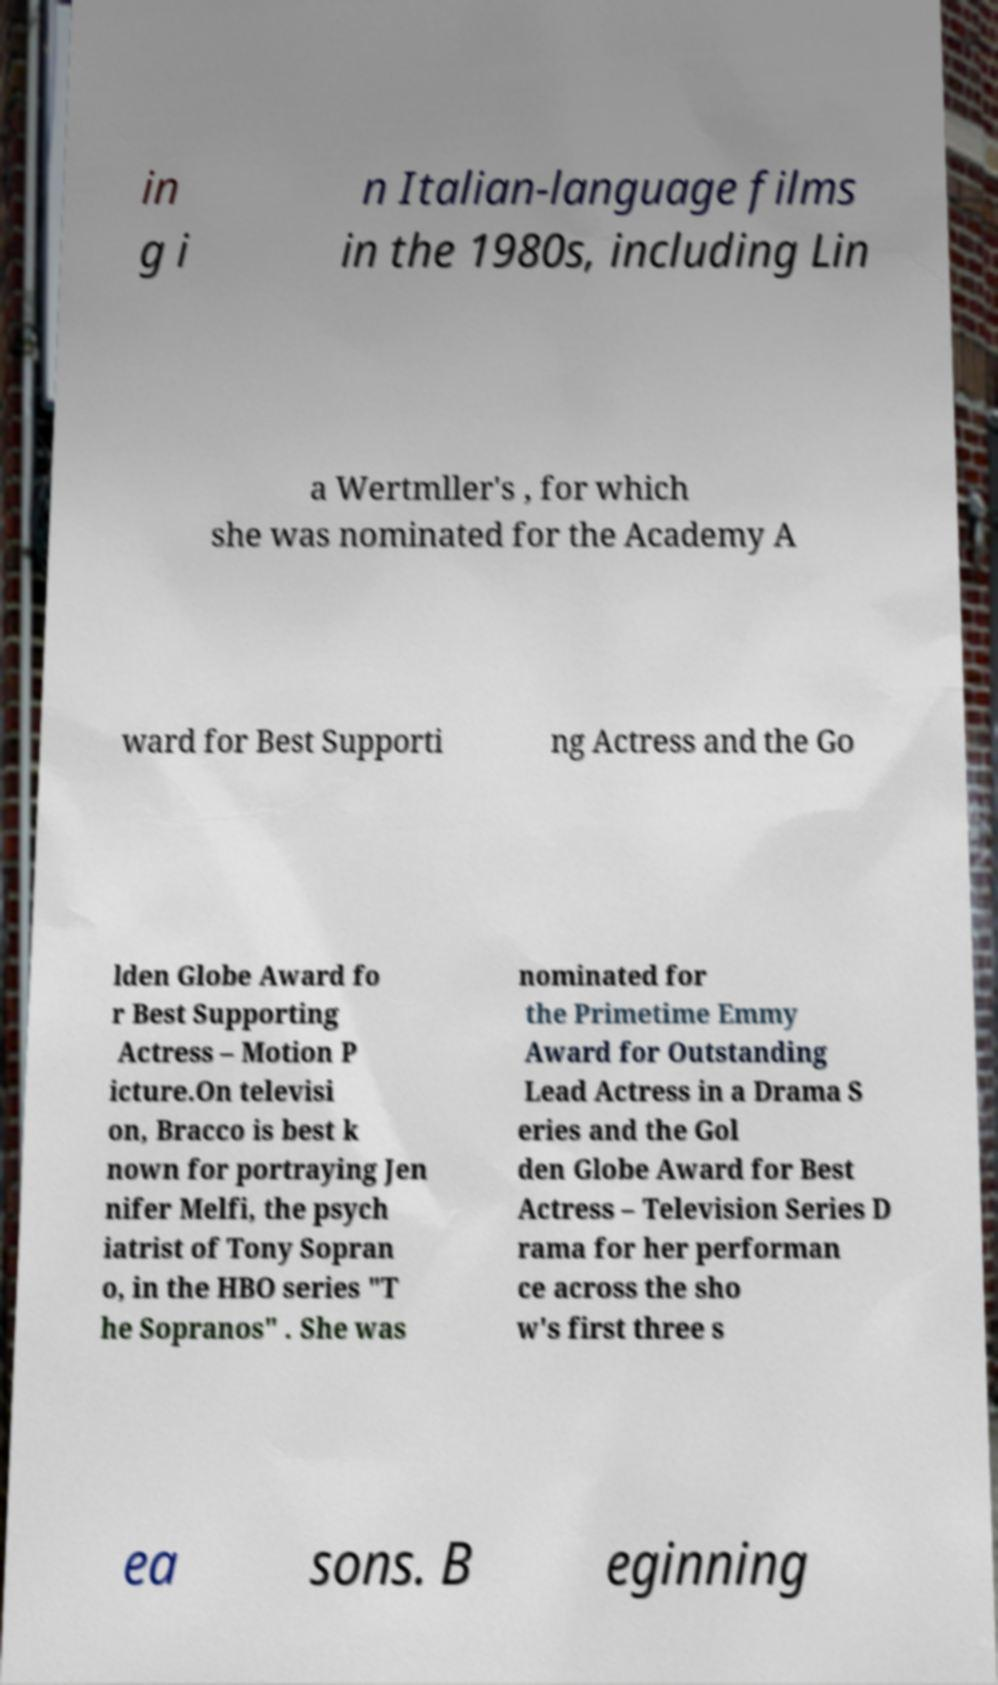Can you read and provide the text displayed in the image?This photo seems to have some interesting text. Can you extract and type it out for me? in g i n Italian-language films in the 1980s, including Lin a Wertmller's , for which she was nominated for the Academy A ward for Best Supporti ng Actress and the Go lden Globe Award fo r Best Supporting Actress – Motion P icture.On televisi on, Bracco is best k nown for portraying Jen nifer Melfi, the psych iatrist of Tony Sopran o, in the HBO series "T he Sopranos" . She was nominated for the Primetime Emmy Award for Outstanding Lead Actress in a Drama S eries and the Gol den Globe Award for Best Actress – Television Series D rama for her performan ce across the sho w's first three s ea sons. B eginning 